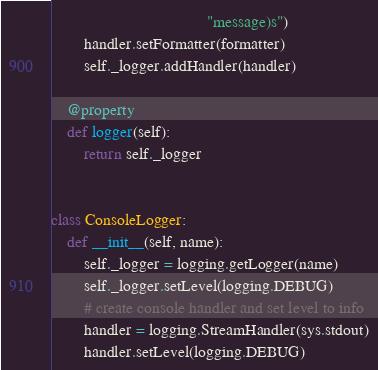Convert code to text. <code><loc_0><loc_0><loc_500><loc_500><_Python_>                                      "message)s")
        handler.setFormatter(formatter)
        self._logger.addHandler(handler)

    @property
    def logger(self):
        return self._logger


class ConsoleLogger:
    def __init__(self, name):
        self._logger = logging.getLogger(name)
        self._logger.setLevel(logging.DEBUG)
        # create console handler and set level to info
        handler = logging.StreamHandler(sys.stdout)
        handler.setLevel(logging.DEBUG)</code> 